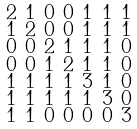<formula> <loc_0><loc_0><loc_500><loc_500>\begin{smallmatrix} 2 & 1 & 0 & 0 & 1 & 1 & 1 \\ 1 & 2 & 0 & 0 & 1 & 1 & 1 \\ 0 & 0 & 2 & 1 & 1 & 1 & 0 \\ 0 & 0 & 1 & 2 & 1 & 1 & 0 \\ 1 & 1 & 1 & 1 & 3 & 1 & 0 \\ 1 & 1 & 1 & 1 & 1 & 3 & 0 \\ 1 & 1 & 0 & 0 & 0 & 0 & 3 \end{smallmatrix}</formula> 